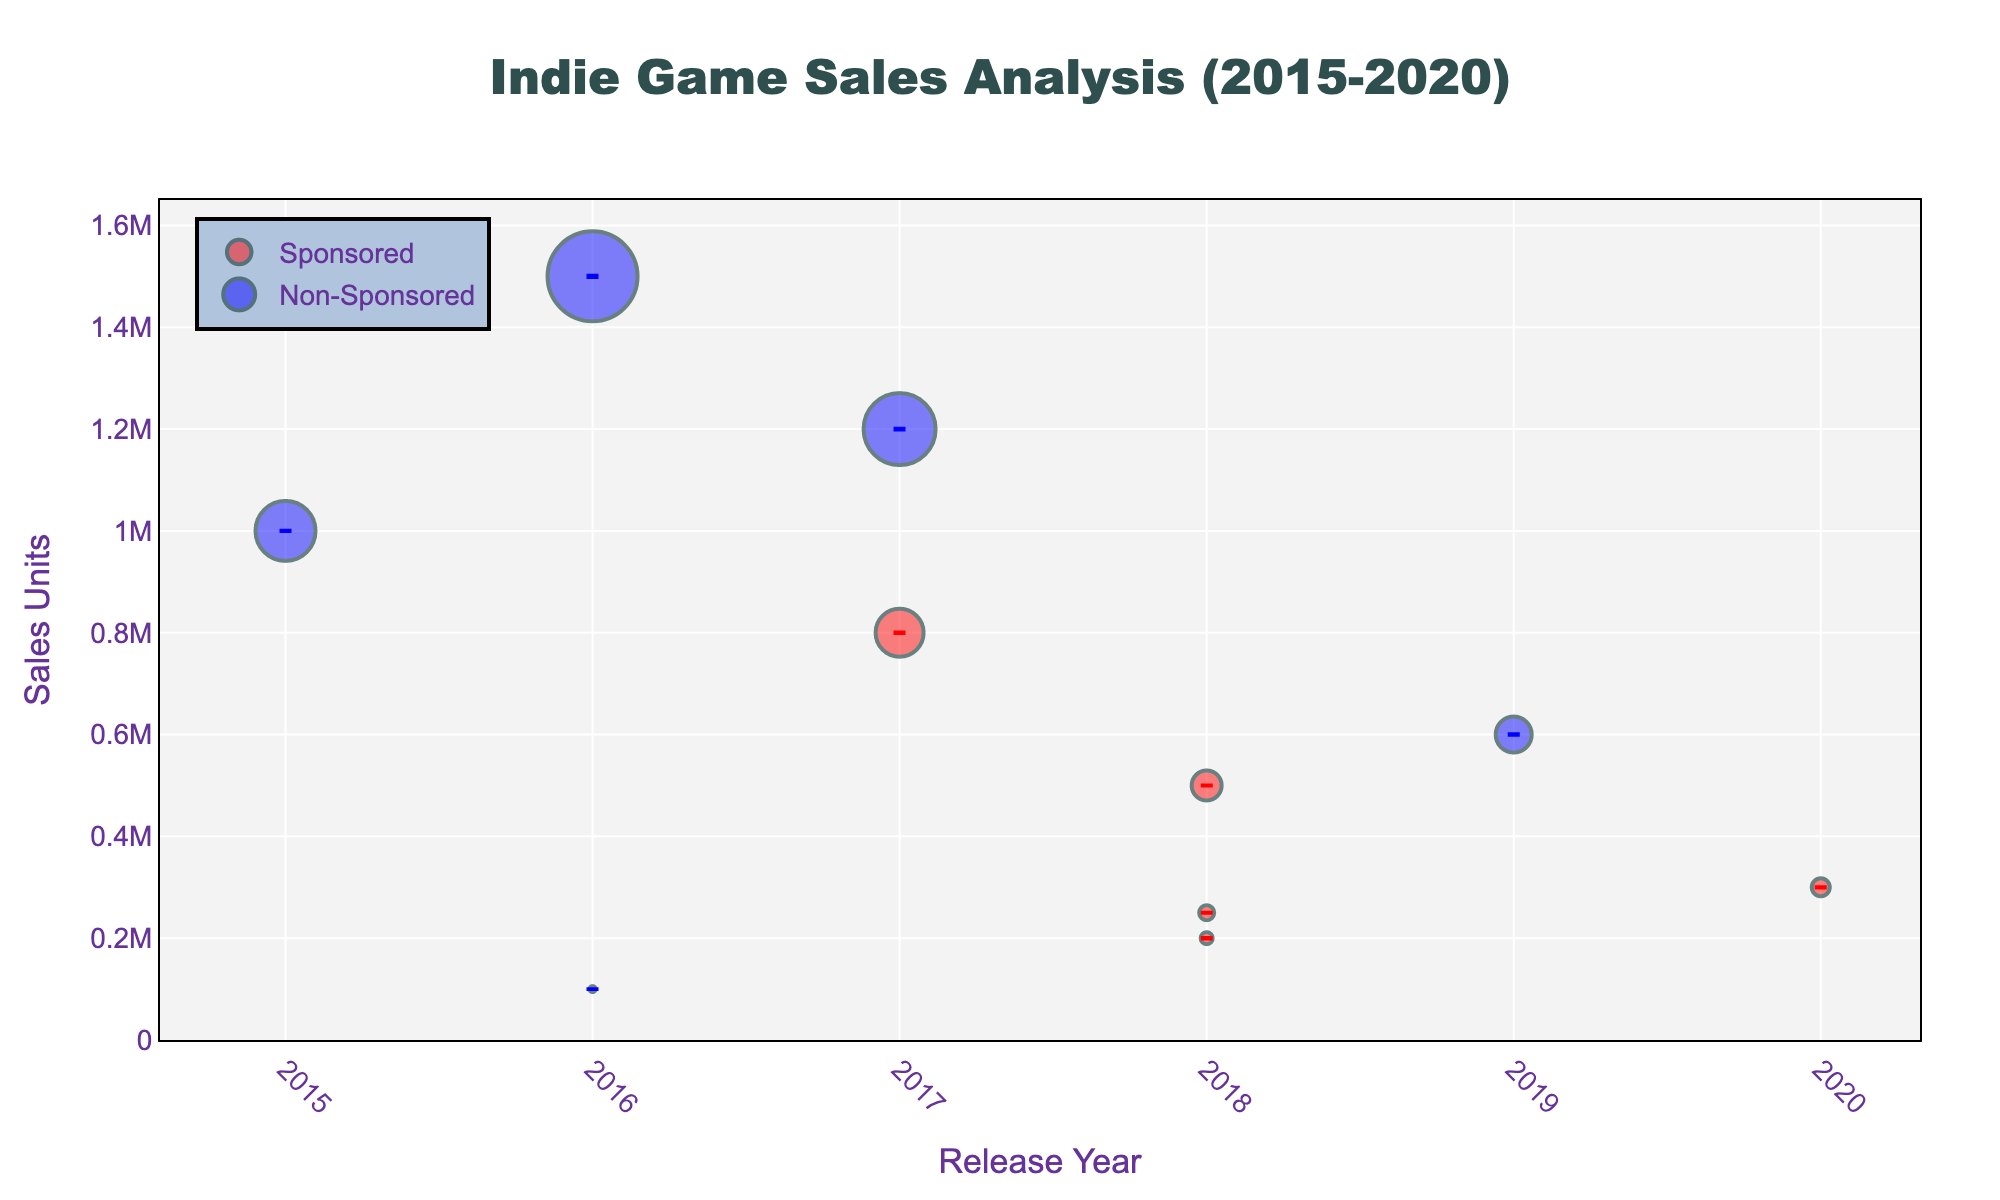What's the title of the plot? The title is prominently displayed at the top of the figure. It reads "Indie Game Sales Analysis (2015-2020)".
Answer: Indie Game Sales Analysis (2015-2020) What is represented by the red markers? The red markers represent the sales units of sponsored indie games. This is apparent from the marker legend in the plot.
Answer: Sponsored indie games Which game had the highest sales units, and how many units were sold? The game with the highest sales units is "Stardew Valley," represented by the highest data point on the y-axis among the markers. It sold 1,500,000 units.
Answer: Stardew Valley, 1,500,000 units What is the difference in sales units between "Oxenfree" and "Cuphead"? "Oxenfree" sold 100,000 units, while "Cuphead" sold 1,200,000 units. The difference in sales units is calculated as 1,200,000 - 100,000.
Answer: 1,100,000 units Which year had the most indie game releases in the dataset? Looking at the x-axis for the cluster of data points, the year 2018 had the highest concentration of points, indicating the most game releases.
Answer: 2018 How do the error bars of sponsored and non-sponsored games differ in color? From the plot, the error bars for sponsored games are red, while the error bars for non-sponsored games are blue.
Answer: Red for sponsored, blue for non-sponsored Which sponsored game listed had the smallest error bar, and what is its value? "Celeste" has the smallest error bar among sponsored games, indicated visually by the length of the error bar. Its error bar value is 1000 units.
Answer: Celeste, 1000 units Compare the sales units of "Hollow Knight" and "Slay the Spire". Which game sold more units? "Hollow Knight" and "Slay the Spire" are represented by markers in the years 2017 and 2019, respectively. "Hollow Knight" sold 800,000 units, whereas "Slay the Spire" sold 600,000 units. Thus, "Hollow Knight" sold more units.
Answer: Hollow Knight What is the average sales units of non-sponsored games in the data provided? Non-sponsored games' sales units are 1,500,000 (Stardew Valley), 1,000,000 (Undertale), 600,000 (Slay the Spire), and 1,200,000 (Cuphead). The average sales units are calculated as (1,500,000 + 1,000,000 + 600,000 + 1,200,000) / 4.
Answer: 1,075,000 units In which year did the sponsored game with the highest revenue release, and what is that revenue? Hovering over the markers shows the details. "Celeste" released in 2018 and had the highest revenue of $15 million.
Answer: 2018, $15 million 